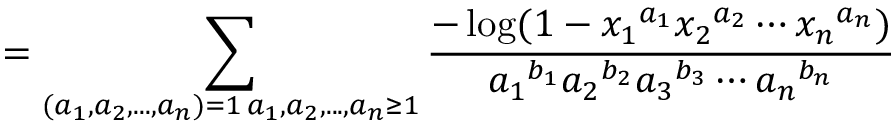<formula> <loc_0><loc_0><loc_500><loc_500>= \sum _ { \substack { ( a _ { 1 } , a _ { 2 } , \dots , a _ { n } ) = 1 \, a _ { 1 } , a _ { 2 } , \dots , a _ { n } \geq 1 } } \frac { - \log ( 1 - { x _ { 1 } } ^ { a _ { 1 } } { x _ { 2 } } ^ { a _ { 2 } } \cdots { x _ { n } } ^ { a _ { n } } ) } { { a _ { 1 } } ^ { b _ { 1 } } { a _ { 2 } } ^ { b _ { 2 } } { a _ { 3 } } ^ { b _ { 3 } } \cdots { a _ { n } } ^ { b _ { n } } }</formula> 